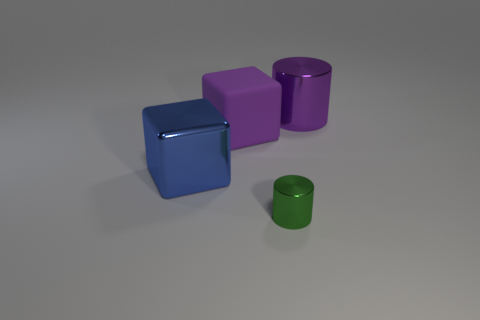There is a purple object that is the same size as the purple cube; what shape is it?
Offer a terse response. Cylinder. The large purple matte object is what shape?
Your answer should be compact. Cube. Does the large object on the right side of the small thing have the same material as the big blue object?
Your answer should be compact. Yes. There is a metal cylinder that is in front of the purple thing that is on the left side of the big shiny cylinder; what size is it?
Your response must be concise. Small. What color is the thing that is both to the right of the big purple rubber thing and behind the blue metallic thing?
Give a very brief answer. Purple. There is another cube that is the same size as the blue block; what material is it?
Provide a short and direct response. Rubber. How many other objects are the same material as the purple block?
Give a very brief answer. 0. There is a cylinder behind the blue metal object; is it the same color as the metal cylinder in front of the purple rubber block?
Keep it short and to the point. No. What shape is the big thing in front of the large block behind the large shiny cube?
Offer a very short reply. Cube. What number of other things are the same color as the big metallic cylinder?
Provide a succinct answer. 1. 